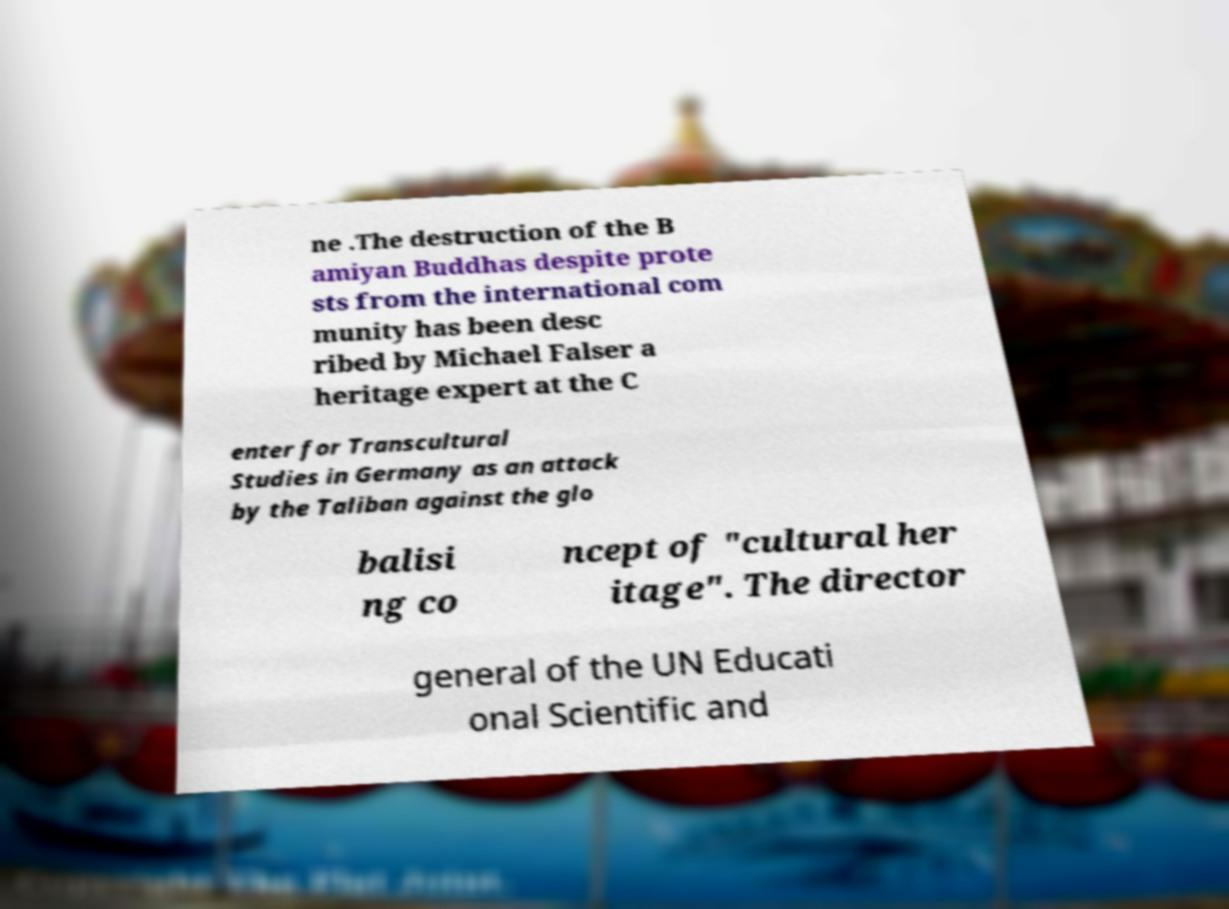Can you read and provide the text displayed in the image?This photo seems to have some interesting text. Can you extract and type it out for me? ne .The destruction of the B amiyan Buddhas despite prote sts from the international com munity has been desc ribed by Michael Falser a heritage expert at the C enter for Transcultural Studies in Germany as an attack by the Taliban against the glo balisi ng co ncept of "cultural her itage". The director general of the UN Educati onal Scientific and 